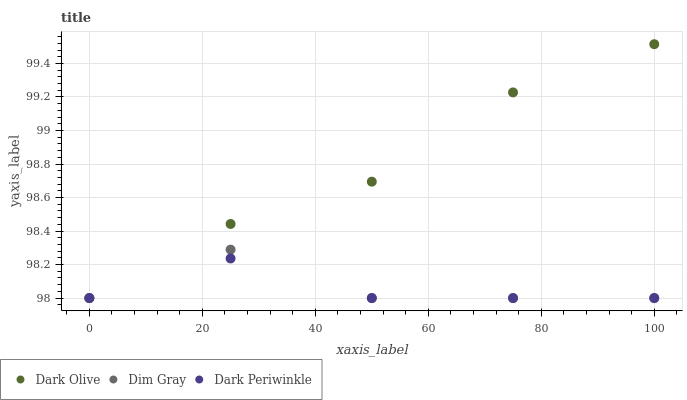Does Dark Periwinkle have the minimum area under the curve?
Answer yes or no. Yes. Does Dark Olive have the maximum area under the curve?
Answer yes or no. Yes. Does Dark Olive have the minimum area under the curve?
Answer yes or no. No. Does Dark Periwinkle have the maximum area under the curve?
Answer yes or no. No. Is Dark Periwinkle the smoothest?
Answer yes or no. Yes. Is Dim Gray the roughest?
Answer yes or no. Yes. Is Dark Olive the smoothest?
Answer yes or no. No. Is Dark Olive the roughest?
Answer yes or no. No. Does Dim Gray have the lowest value?
Answer yes or no. Yes. Does Dark Olive have the highest value?
Answer yes or no. Yes. Does Dark Periwinkle have the highest value?
Answer yes or no. No. Does Dim Gray intersect Dark Periwinkle?
Answer yes or no. Yes. Is Dim Gray less than Dark Periwinkle?
Answer yes or no. No. Is Dim Gray greater than Dark Periwinkle?
Answer yes or no. No. 